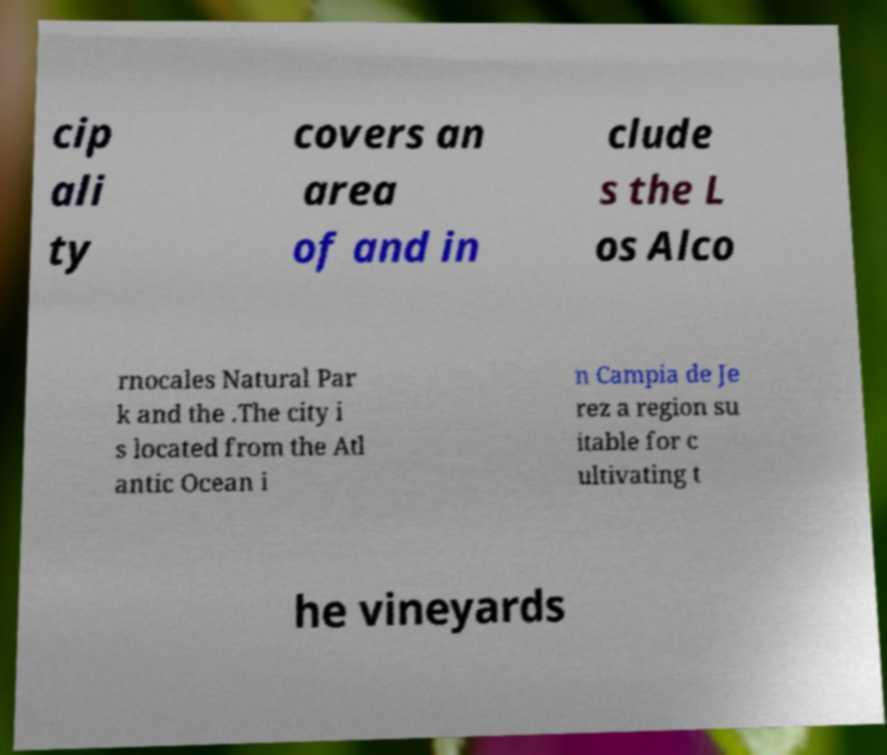There's text embedded in this image that I need extracted. Can you transcribe it verbatim? cip ali ty covers an area of and in clude s the L os Alco rnocales Natural Par k and the .The city i s located from the Atl antic Ocean i n Campia de Je rez a region su itable for c ultivating t he vineyards 